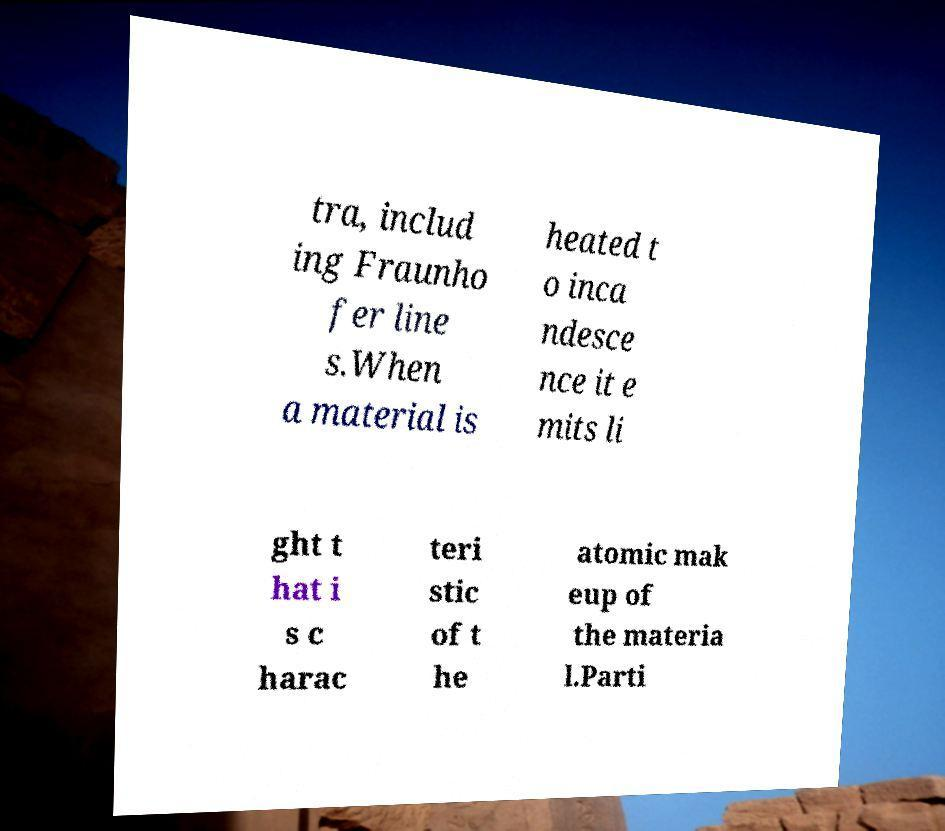Can you accurately transcribe the text from the provided image for me? tra, includ ing Fraunho fer line s.When a material is heated t o inca ndesce nce it e mits li ght t hat i s c harac teri stic of t he atomic mak eup of the materia l.Parti 